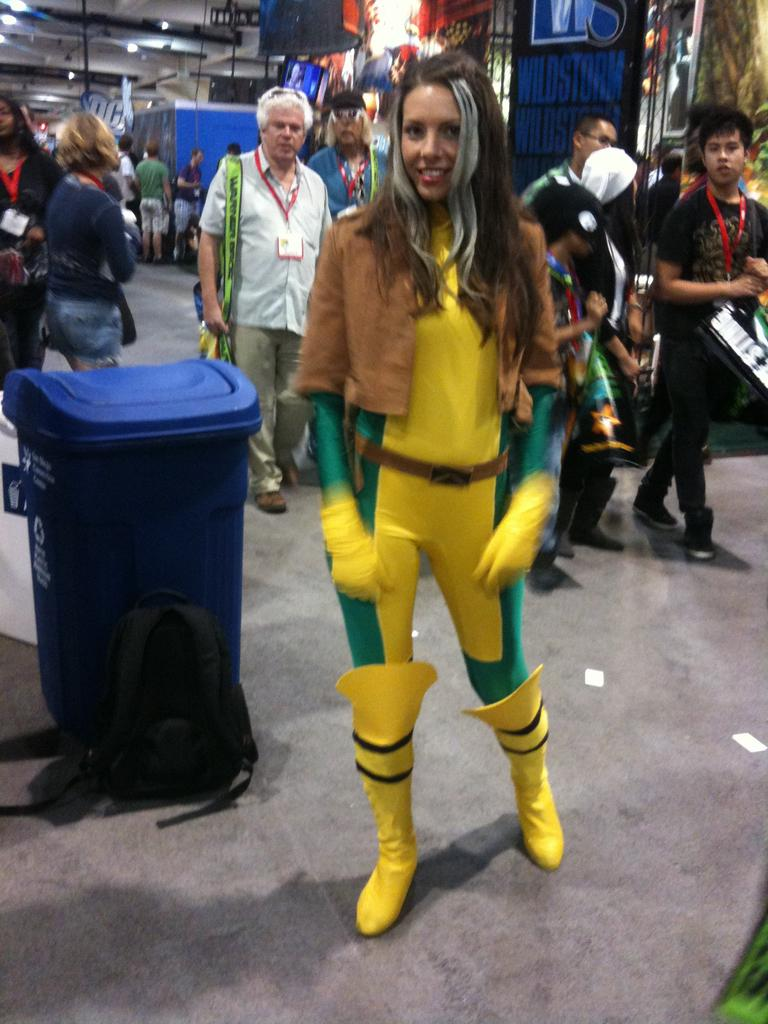Who is present in the image? There is a woman in the image. What object can be seen near the woman? There is a dustbin in the image. What is on the ground in the image? There is a bag on the ground in the image. What can be seen in the background of the image? There is a group of people, lights, and some objects visible in the background of the image. How many jellyfish are swimming in the bag on the ground in the image? There are no jellyfish present in the image, and the bag on the ground does not contain any jellyfish. 